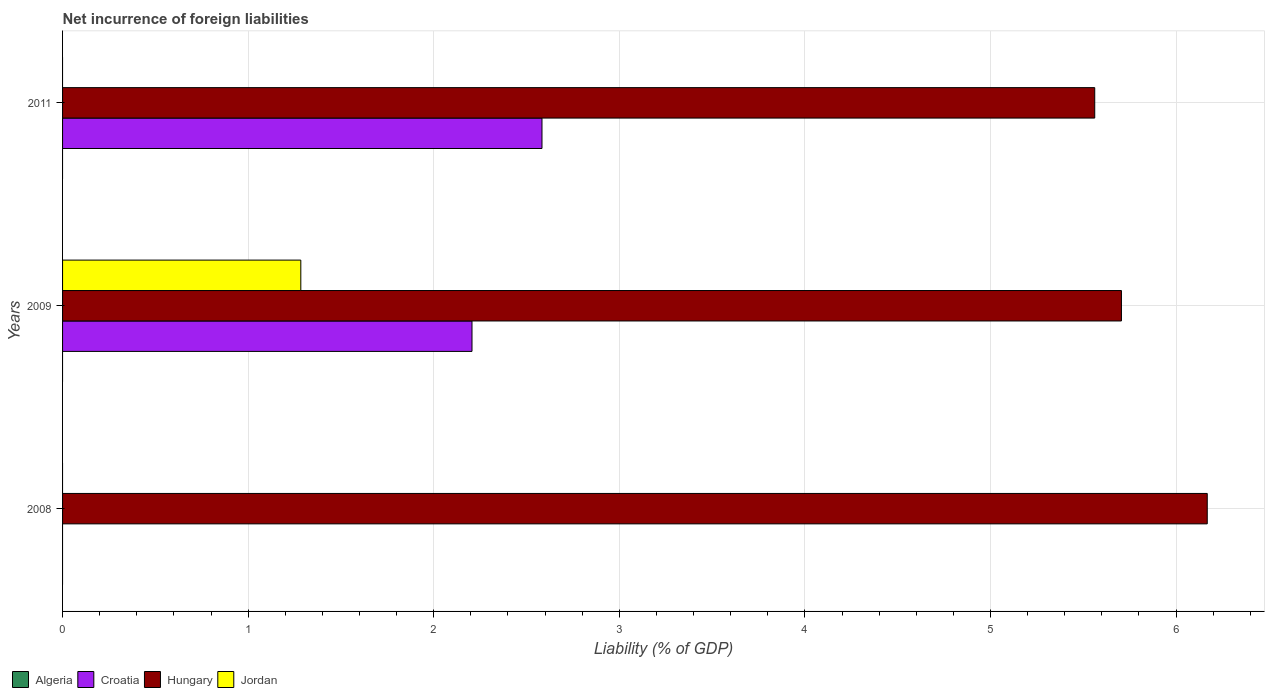Are the number of bars per tick equal to the number of legend labels?
Ensure brevity in your answer.  No. How many bars are there on the 1st tick from the top?
Your answer should be compact. 2. What is the label of the 2nd group of bars from the top?
Your answer should be compact. 2009. Across all years, what is the maximum net incurrence of foreign liabilities in Jordan?
Your response must be concise. 1.28. In which year was the net incurrence of foreign liabilities in Jordan maximum?
Your answer should be very brief. 2009. What is the difference between the net incurrence of foreign liabilities in Hungary in 2009 and that in 2011?
Ensure brevity in your answer.  0.14. What is the difference between the net incurrence of foreign liabilities in Hungary in 2009 and the net incurrence of foreign liabilities in Jordan in 2011?
Keep it short and to the point. 5.71. What is the average net incurrence of foreign liabilities in Croatia per year?
Give a very brief answer. 1.6. In the year 2009, what is the difference between the net incurrence of foreign liabilities in Croatia and net incurrence of foreign liabilities in Jordan?
Your answer should be very brief. 0.92. In how many years, is the net incurrence of foreign liabilities in Hungary greater than 2.8 %?
Provide a succinct answer. 3. What is the ratio of the net incurrence of foreign liabilities in Hungary in 2008 to that in 2009?
Provide a short and direct response. 1.08. What is the difference between the highest and the second highest net incurrence of foreign liabilities in Hungary?
Your answer should be very brief. 0.46. What is the difference between the highest and the lowest net incurrence of foreign liabilities in Hungary?
Provide a succinct answer. 0.61. Is it the case that in every year, the sum of the net incurrence of foreign liabilities in Hungary and net incurrence of foreign liabilities in Algeria is greater than the sum of net incurrence of foreign liabilities in Jordan and net incurrence of foreign liabilities in Croatia?
Your response must be concise. Yes. Is it the case that in every year, the sum of the net incurrence of foreign liabilities in Hungary and net incurrence of foreign liabilities in Jordan is greater than the net incurrence of foreign liabilities in Croatia?
Provide a succinct answer. Yes. How many bars are there?
Provide a short and direct response. 6. Does the graph contain grids?
Give a very brief answer. Yes. Where does the legend appear in the graph?
Your answer should be compact. Bottom left. How are the legend labels stacked?
Your answer should be very brief. Horizontal. What is the title of the graph?
Keep it short and to the point. Net incurrence of foreign liabilities. Does "Euro area" appear as one of the legend labels in the graph?
Offer a very short reply. No. What is the label or title of the X-axis?
Keep it short and to the point. Liability (% of GDP). What is the Liability (% of GDP) of Hungary in 2008?
Offer a very short reply. 6.17. What is the Liability (% of GDP) of Jordan in 2008?
Offer a very short reply. 0. What is the Liability (% of GDP) of Croatia in 2009?
Your response must be concise. 2.21. What is the Liability (% of GDP) in Hungary in 2009?
Make the answer very short. 5.71. What is the Liability (% of GDP) in Jordan in 2009?
Your answer should be very brief. 1.28. What is the Liability (% of GDP) in Algeria in 2011?
Your answer should be compact. 0. What is the Liability (% of GDP) in Croatia in 2011?
Your answer should be very brief. 2.58. What is the Liability (% of GDP) of Hungary in 2011?
Provide a short and direct response. 5.56. Across all years, what is the maximum Liability (% of GDP) in Croatia?
Offer a very short reply. 2.58. Across all years, what is the maximum Liability (% of GDP) of Hungary?
Offer a terse response. 6.17. Across all years, what is the maximum Liability (% of GDP) of Jordan?
Give a very brief answer. 1.28. Across all years, what is the minimum Liability (% of GDP) in Hungary?
Offer a very short reply. 5.56. What is the total Liability (% of GDP) of Croatia in the graph?
Your answer should be very brief. 4.79. What is the total Liability (% of GDP) in Hungary in the graph?
Give a very brief answer. 17.44. What is the total Liability (% of GDP) in Jordan in the graph?
Keep it short and to the point. 1.28. What is the difference between the Liability (% of GDP) of Hungary in 2008 and that in 2009?
Provide a succinct answer. 0.46. What is the difference between the Liability (% of GDP) of Hungary in 2008 and that in 2011?
Ensure brevity in your answer.  0.61. What is the difference between the Liability (% of GDP) of Croatia in 2009 and that in 2011?
Give a very brief answer. -0.38. What is the difference between the Liability (% of GDP) in Hungary in 2009 and that in 2011?
Provide a succinct answer. 0.14. What is the difference between the Liability (% of GDP) of Hungary in 2008 and the Liability (% of GDP) of Jordan in 2009?
Your response must be concise. 4.88. What is the difference between the Liability (% of GDP) of Croatia in 2009 and the Liability (% of GDP) of Hungary in 2011?
Offer a terse response. -3.36. What is the average Liability (% of GDP) of Algeria per year?
Your response must be concise. 0. What is the average Liability (% of GDP) in Croatia per year?
Your answer should be very brief. 1.6. What is the average Liability (% of GDP) of Hungary per year?
Ensure brevity in your answer.  5.81. What is the average Liability (% of GDP) of Jordan per year?
Your answer should be compact. 0.43. In the year 2009, what is the difference between the Liability (% of GDP) of Croatia and Liability (% of GDP) of Hungary?
Offer a terse response. -3.5. In the year 2009, what is the difference between the Liability (% of GDP) in Croatia and Liability (% of GDP) in Jordan?
Make the answer very short. 0.92. In the year 2009, what is the difference between the Liability (% of GDP) in Hungary and Liability (% of GDP) in Jordan?
Provide a short and direct response. 4.42. In the year 2011, what is the difference between the Liability (% of GDP) in Croatia and Liability (% of GDP) in Hungary?
Your answer should be compact. -2.98. What is the ratio of the Liability (% of GDP) in Hungary in 2008 to that in 2009?
Offer a terse response. 1.08. What is the ratio of the Liability (% of GDP) of Hungary in 2008 to that in 2011?
Offer a very short reply. 1.11. What is the ratio of the Liability (% of GDP) of Croatia in 2009 to that in 2011?
Your answer should be compact. 0.85. What is the ratio of the Liability (% of GDP) in Hungary in 2009 to that in 2011?
Your answer should be very brief. 1.03. What is the difference between the highest and the second highest Liability (% of GDP) of Hungary?
Provide a short and direct response. 0.46. What is the difference between the highest and the lowest Liability (% of GDP) of Croatia?
Keep it short and to the point. 2.58. What is the difference between the highest and the lowest Liability (% of GDP) in Hungary?
Make the answer very short. 0.61. What is the difference between the highest and the lowest Liability (% of GDP) of Jordan?
Your answer should be very brief. 1.28. 